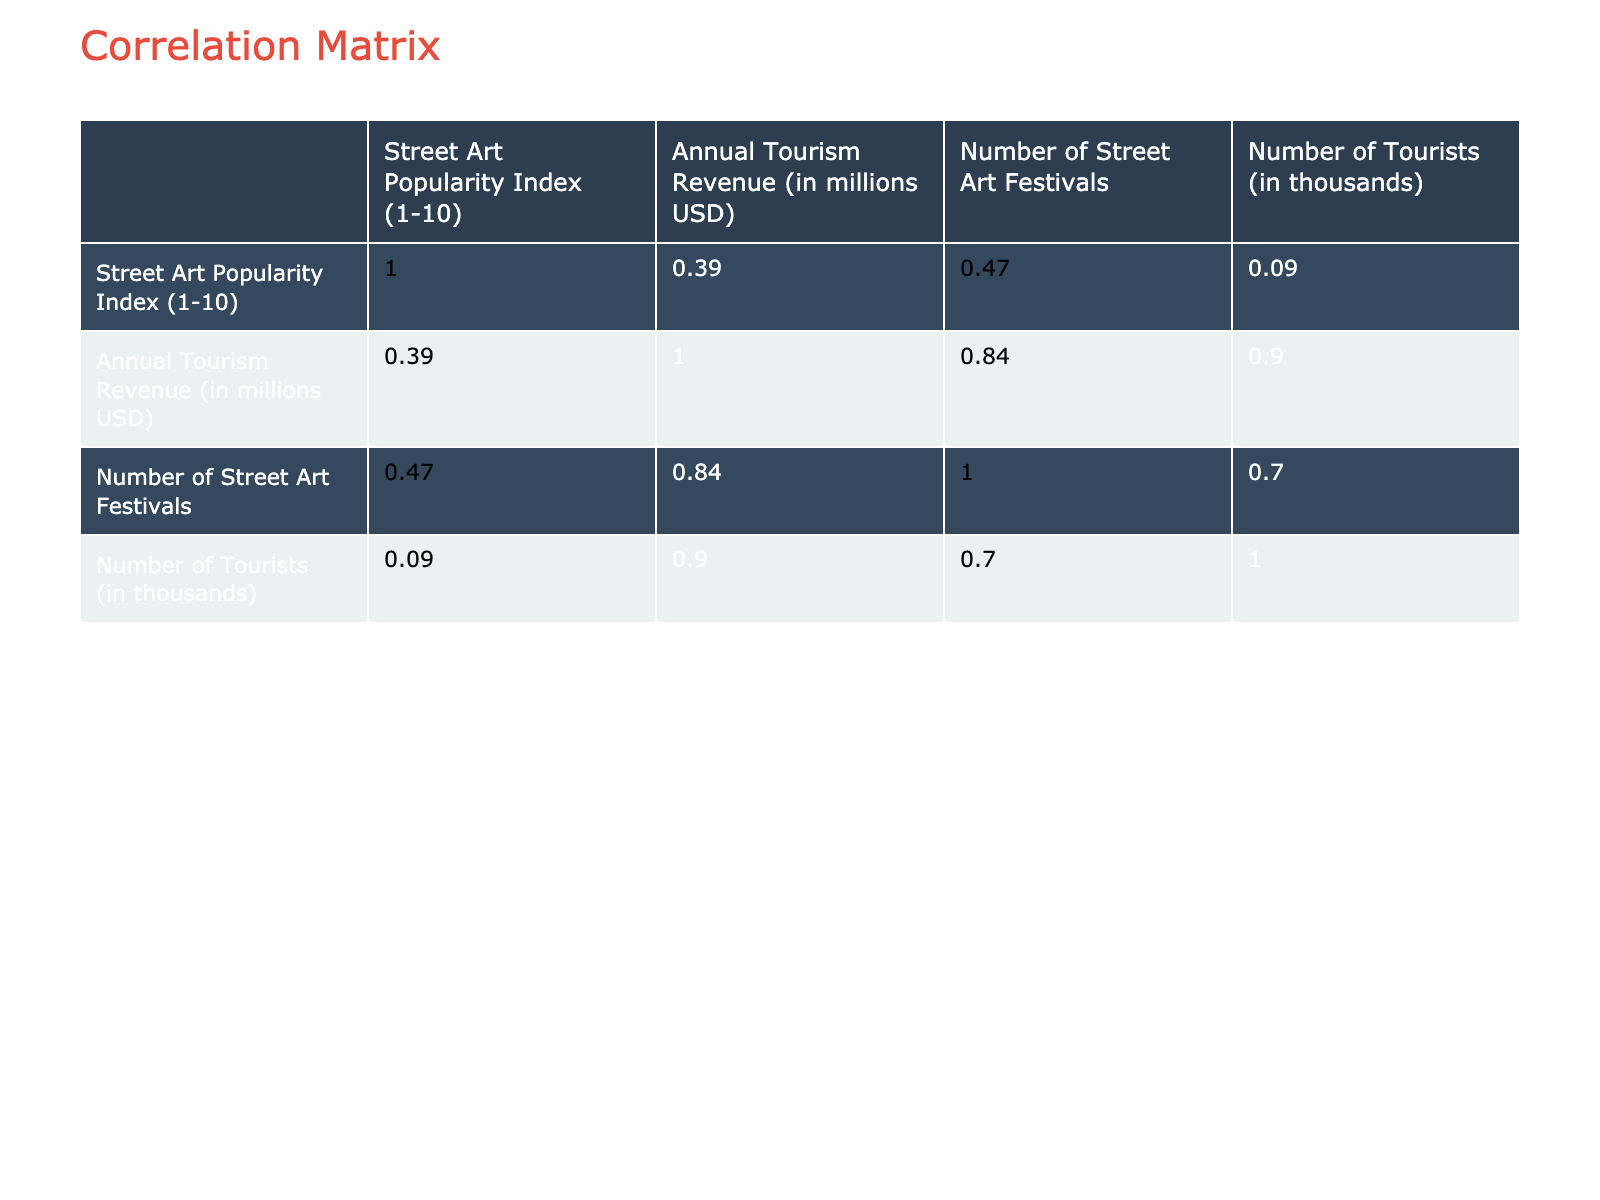What is the Street Art Popularity Index for New York? According to the table, New York has a Street Art Popularity Index of 10, which is the highest value listed.
Answer: 10 Is there a correlation between Street Art Popularity Index and Annual Tourism Revenue? To determine this, we look at the correlation coefficient in the table. If the value is close to 1 or -1, it indicates a strong correlation. It appears to be a positive correlation since cities with a higher Street Art Popularity Index tend to have higher tourism revenues.
Answer: Yes What city has the highest Annual Tourism Revenue and what is the value? The city with the highest Annual Tourism Revenue is New York, with a revenue of 7000 million USD.
Answer: 7000 Which city has a Street Art Popularity Index of 6 and what is its Annual Tourism Revenue? Toronto has a Street Art Popularity Index of 6, and its Annual Tourism Revenue is 1300 million USD.
Answer: Toronto, 1300 What is the average Annual Tourism Revenue for cities with a Street Art Popularity Index of 8? The cities with a Street Art Popularity Index of 8 are Berlin and Athens, whose Annual Tourism Revenues are 2000 million USD and 1700 million USD respectively. To find the average: (2000 + 1700) / 2 = 1850.
Answer: 1850 Is it true that cities with more street art festivals generate higher tourism revenue? To investigate this, we analyze the data points from the table. For example, New York has 10 festivals and 7000 million USD, whereas Banksy City has 2 festivals and only 800 million USD. However, Miami has only 3 festivals with lower revenue. This suggests that while there's evidence of a trend, it's not conclusive across all cities.
Answer: No What is the total number of tourists in thousands for all cities with a Street Art Popularity Index of 7? The cities with a popularity index of 7 are Melbourne and Buenos Aires. The number of tourists for Melbourne is 5000 and for Buenos Aires is 4000. Adding these together: 5000 + 4000 = 9000.
Answer: 9000 Which city has the lowest Annual Tourism Revenue, and what is that value? Banksy City (Bristol) has the lowest Annual Tourism Revenue at 800 million USD.
Answer: 800 Is the average Street Art Popularity Index of cities with more than 5 million USD in tourism revenue higher than that of cities with less? The cities with more than 5 million USD in revenue are New York, Paris, and Los Angeles, with popularity indexes of 10, 6, and 9 respectively. Their average is (10 + 6 + 9) / 3 = 8.33. The rest (12) have a lower average like Banksy City at 9, Miami at 5, etc. The comparison shows 8.33 is higher.
Answer: Yes 